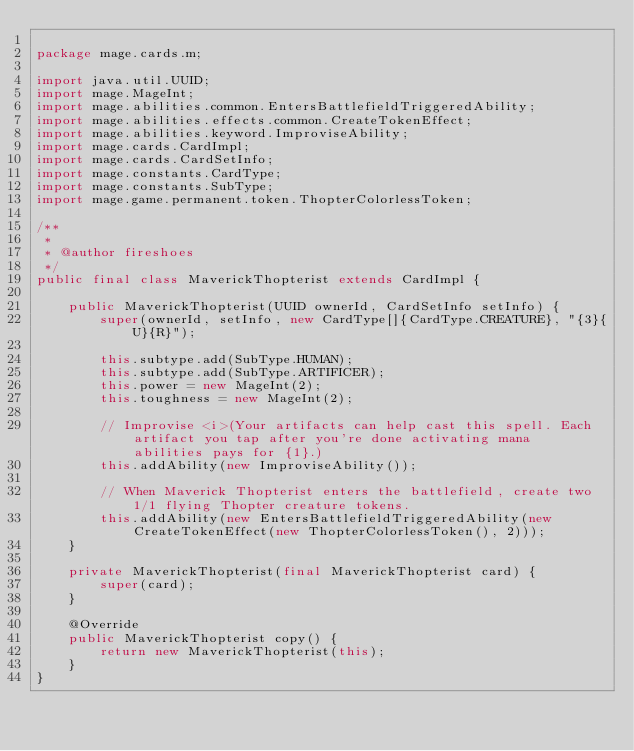Convert code to text. <code><loc_0><loc_0><loc_500><loc_500><_Java_>
package mage.cards.m;

import java.util.UUID;
import mage.MageInt;
import mage.abilities.common.EntersBattlefieldTriggeredAbility;
import mage.abilities.effects.common.CreateTokenEffect;
import mage.abilities.keyword.ImproviseAbility;
import mage.cards.CardImpl;
import mage.cards.CardSetInfo;
import mage.constants.CardType;
import mage.constants.SubType;
import mage.game.permanent.token.ThopterColorlessToken;

/**
 *
 * @author fireshoes
 */
public final class MaverickThopterist extends CardImpl {

    public MaverickThopterist(UUID ownerId, CardSetInfo setInfo) {
        super(ownerId, setInfo, new CardType[]{CardType.CREATURE}, "{3}{U}{R}");

        this.subtype.add(SubType.HUMAN);
        this.subtype.add(SubType.ARTIFICER);
        this.power = new MageInt(2);
        this.toughness = new MageInt(2);

        // Improvise <i>(Your artifacts can help cast this spell. Each artifact you tap after you're done activating mana abilities pays for {1}.)
        this.addAbility(new ImproviseAbility());

        // When Maverick Thopterist enters the battlefield, create two 1/1 flying Thopter creature tokens.
        this.addAbility(new EntersBattlefieldTriggeredAbility(new CreateTokenEffect(new ThopterColorlessToken(), 2)));
    }

    private MaverickThopterist(final MaverickThopterist card) {
        super(card);
    }

    @Override
    public MaverickThopterist copy() {
        return new MaverickThopterist(this);
    }
}
</code> 